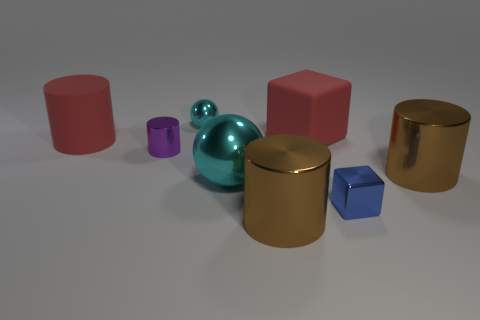What size is the rubber object that is the same color as the large matte cylinder?
Make the answer very short. Large. There is a purple cylinder; is its size the same as the ball that is behind the small purple cylinder?
Ensure brevity in your answer.  Yes. How many other objects are there of the same color as the large matte cylinder?
Your answer should be compact. 1. There is a small cube; are there any large brown shiny cylinders left of it?
Offer a very short reply. Yes. How many objects are either small yellow spheres or cylinders that are in front of the blue shiny object?
Offer a terse response. 1. Are there any cyan metal objects behind the small purple cylinder left of the big metal sphere?
Your answer should be compact. Yes. The big brown metal object that is to the right of the blue block in front of the cyan ball that is to the left of the large ball is what shape?
Your answer should be compact. Cylinder. There is a cylinder that is to the left of the tiny sphere and in front of the large matte cylinder; what color is it?
Provide a succinct answer. Purple. There is a shiny thing behind the big red cylinder; what shape is it?
Provide a succinct answer. Sphere. There is a tiny cyan thing that is made of the same material as the big cyan object; what is its shape?
Your answer should be very brief. Sphere. 